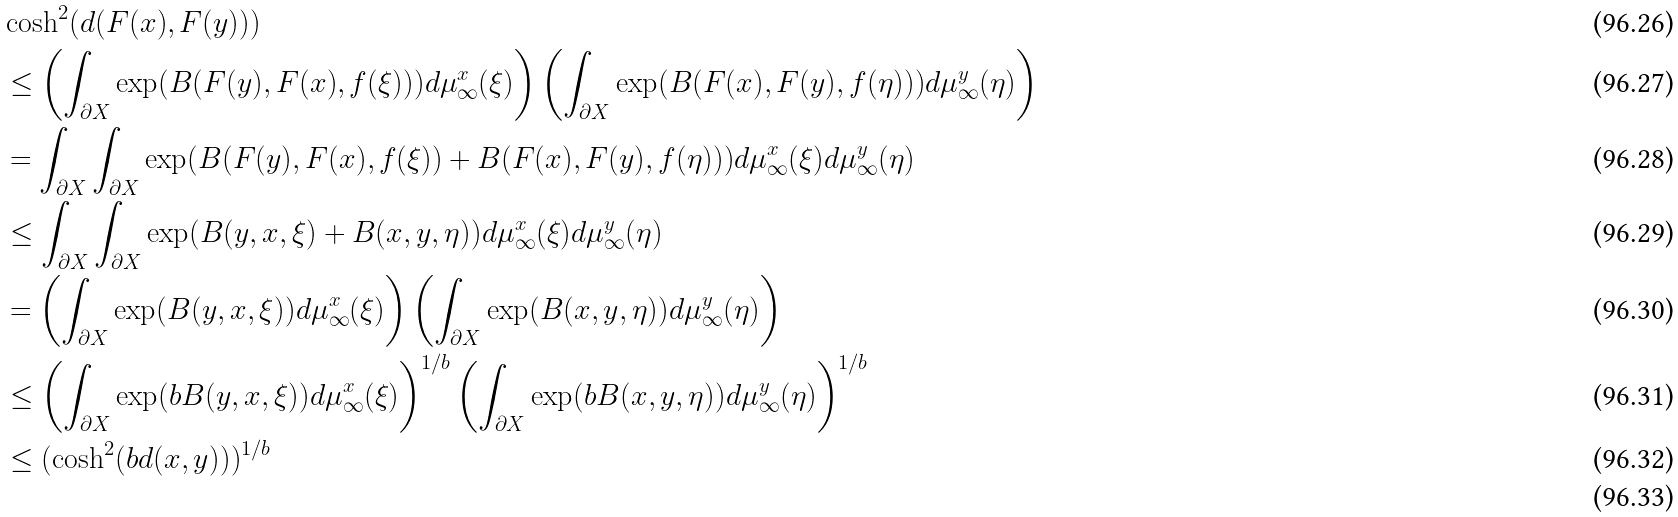Convert formula to latex. <formula><loc_0><loc_0><loc_500><loc_500>& \cosh ^ { 2 } ( d ( F ( x ) , F ( y ) ) ) \\ & \leq \left ( \int _ { \partial X } \exp ( B ( F ( y ) , F ( x ) , f ( \xi ) ) ) d \mu ^ { x } _ { \infty } ( \xi ) \right ) \left ( \int _ { \partial X } \exp ( B ( F ( x ) , F ( y ) , f ( \eta ) ) ) d \mu ^ { y } _ { \infty } ( \eta ) \right ) \\ & = \int _ { \partial X } \int _ { \partial X } \exp ( B ( F ( y ) , F ( x ) , f ( \xi ) ) + B ( F ( x ) , F ( y ) , f ( \eta ) ) ) d \mu ^ { x } _ { \infty } ( \xi ) d \mu ^ { y } _ { \infty } ( \eta ) \\ & \leq \int _ { \partial X } \int _ { \partial X } \exp ( B ( y , x , \xi ) + B ( x , y , \eta ) ) d \mu ^ { x } _ { \infty } ( \xi ) d \mu ^ { y } _ { \infty } ( \eta ) \\ & = \left ( \int _ { \partial X } \exp ( B ( y , x , \xi ) ) d \mu ^ { x } _ { \infty } ( \xi ) \right ) \left ( \int _ { \partial X } \exp ( B ( x , y , \eta ) ) d \mu ^ { y } _ { \infty } ( \eta ) \right ) \\ & \leq \left ( \int _ { \partial X } \exp ( b B ( y , x , \xi ) ) d \mu ^ { x } _ { \infty } ( \xi ) \right ) ^ { 1 / b } \left ( \int _ { \partial X } \exp ( b B ( x , y , \eta ) ) d \mu ^ { y } _ { \infty } ( \eta ) \right ) ^ { 1 / b } \\ & \leq ( \cosh ^ { 2 } ( b d ( x , y ) ) ) ^ { 1 / b } \\</formula> 